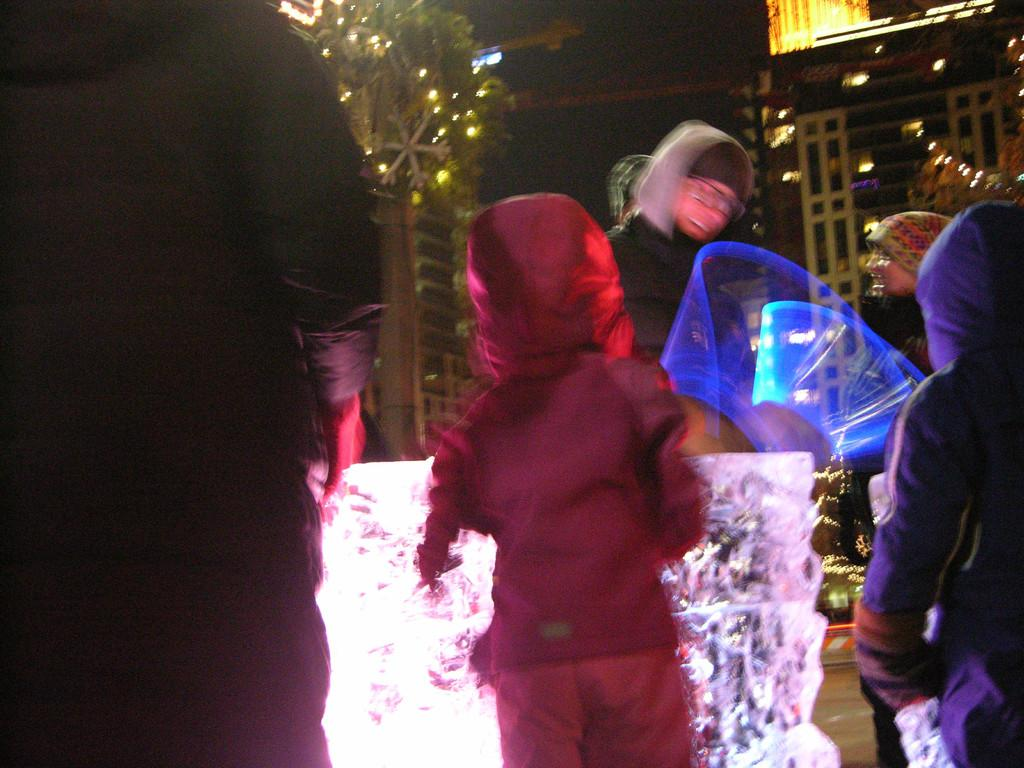What type of natural element can be seen in the image? There is a tree in the image. What type of structure is present in the image? There is a house in the image. Who is present in the image? There are people standing in the image. What are the people wearing on their heads? The people are wearing caps on their heads. What weather phenomenon can be seen in the image? There is lightning visible in the image. What type of quiver can be seen in the image? There is no quiver present in the image. How do the people in the image control the lightning? The people in the image do not control the lightning; it is a natural weather phenomenon. 